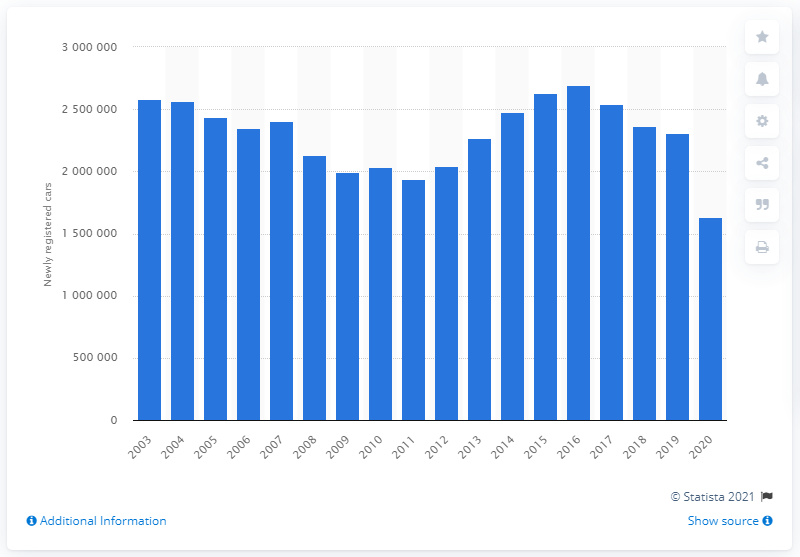Highlight a few significant elements in this photo. In 2020, a total of 163,106 new passenger cars were registered in the United Kingdom. 